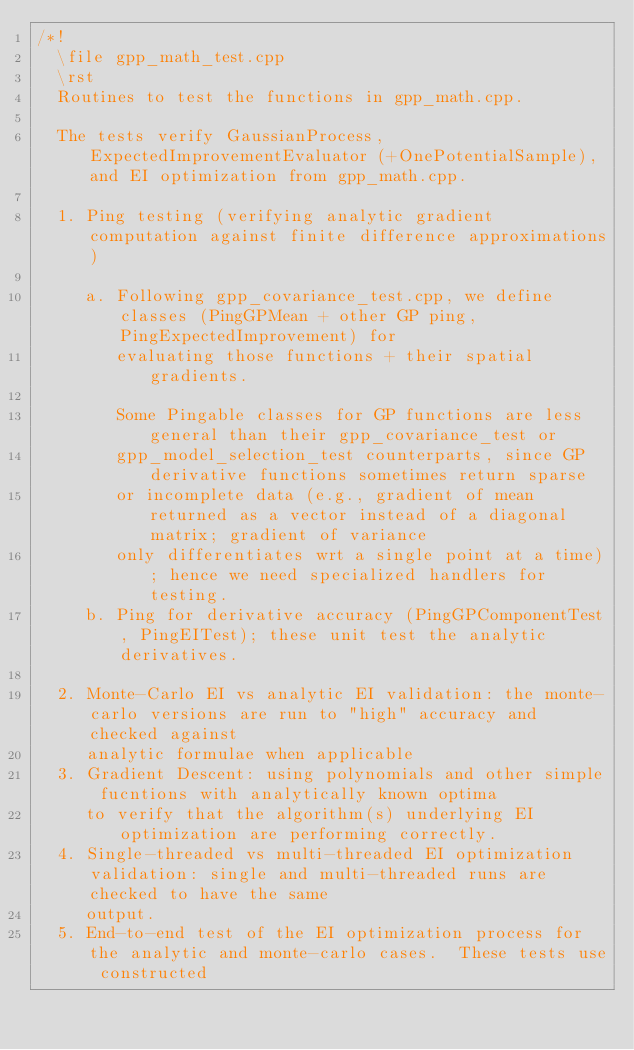<code> <loc_0><loc_0><loc_500><loc_500><_C++_>/*!
  \file gpp_math_test.cpp
  \rst
  Routines to test the functions in gpp_math.cpp.

  The tests verify GaussianProcess, ExpectedImprovementEvaluator (+OnePotentialSample), and EI optimization from gpp_math.cpp.

  1. Ping testing (verifying analytic gradient computation against finite difference approximations)

     a. Following gpp_covariance_test.cpp, we define classes (PingGPMean + other GP ping, PingExpectedImprovement) for
        evaluating those functions + their spatial gradients.

        Some Pingable classes for GP functions are less general than their gpp_covariance_test or
        gpp_model_selection_test counterparts, since GP derivative functions sometimes return sparse
        or incomplete data (e.g., gradient of mean returned as a vector instead of a diagonal matrix; gradient of variance
        only differentiates wrt a single point at a time); hence we need specialized handlers for testing.
     b. Ping for derivative accuracy (PingGPComponentTest, PingEITest); these unit test the analytic derivatives.

  2. Monte-Carlo EI vs analytic EI validation: the monte-carlo versions are run to "high" accuracy and checked against
     analytic formulae when applicable
  3. Gradient Descent: using polynomials and other simple fucntions with analytically known optima
     to verify that the algorithm(s) underlying EI optimization are performing correctly.
  4. Single-threaded vs multi-threaded EI optimization validation: single and multi-threaded runs are checked to have the same
     output.
  5. End-to-end test of the EI optimization process for the analytic and monte-carlo cases.  These tests use constructed</code> 